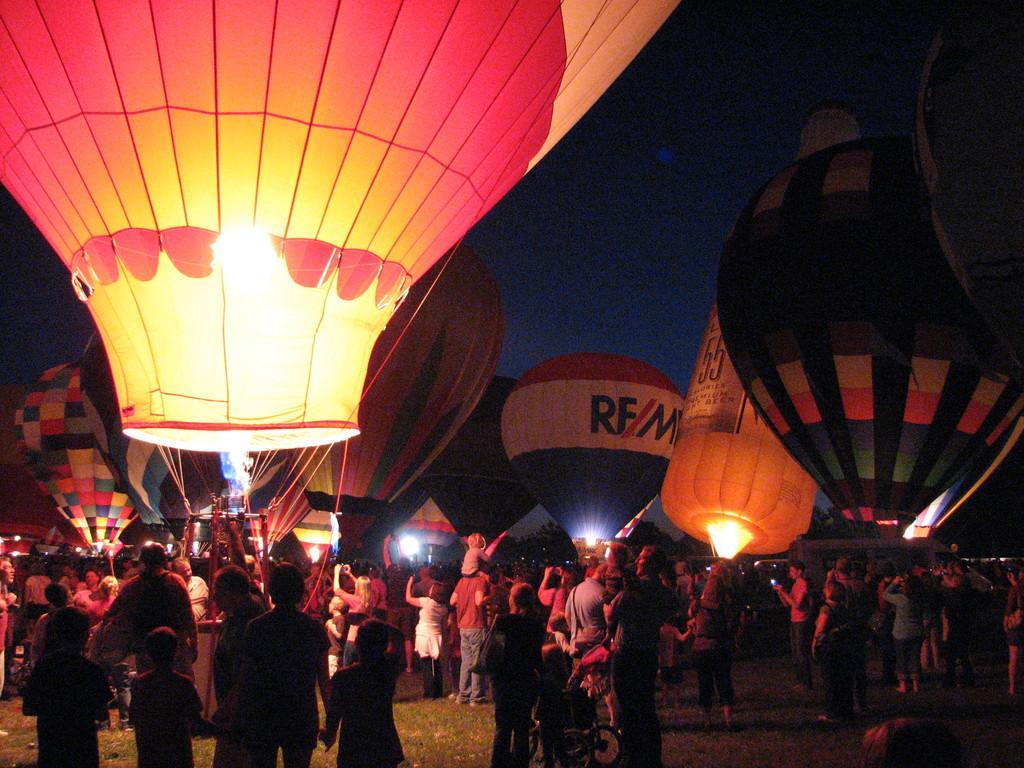Describe this image in one or two sentences. In this image there are so many people standing on the ground and holding the hot air balloons. In the middle there is a person who is lighting the hot air balloons. This image is taken during the night time. In this image we can see there are so many hot air balloons one beside the other. 